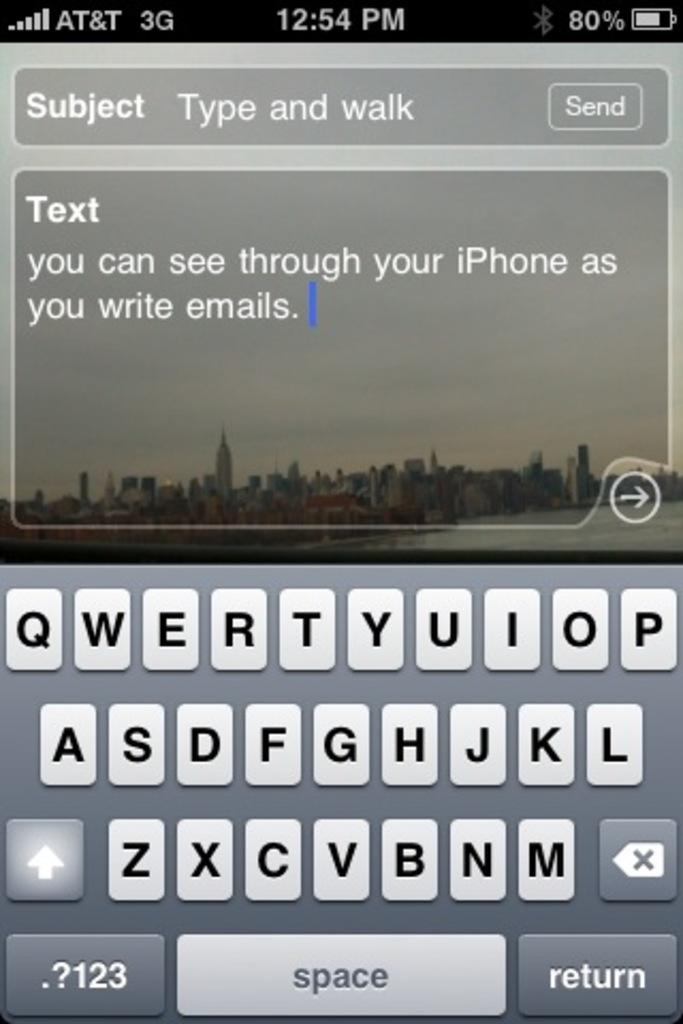<image>
Create a compact narrative representing the image presented. Iphone screen that shows a text getting typed 